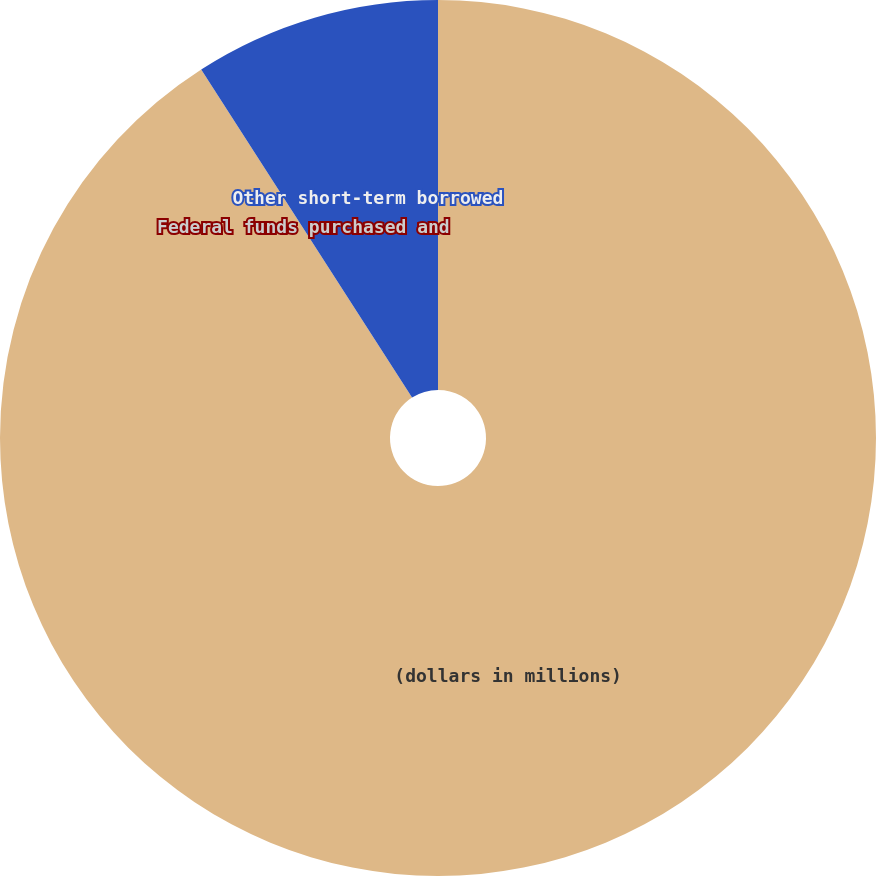Convert chart. <chart><loc_0><loc_0><loc_500><loc_500><pie_chart><fcel>(dollars in millions)<fcel>Federal funds purchased and<fcel>Other short-term borrowed<nl><fcel>90.9%<fcel>0.0%<fcel>9.09%<nl></chart> 